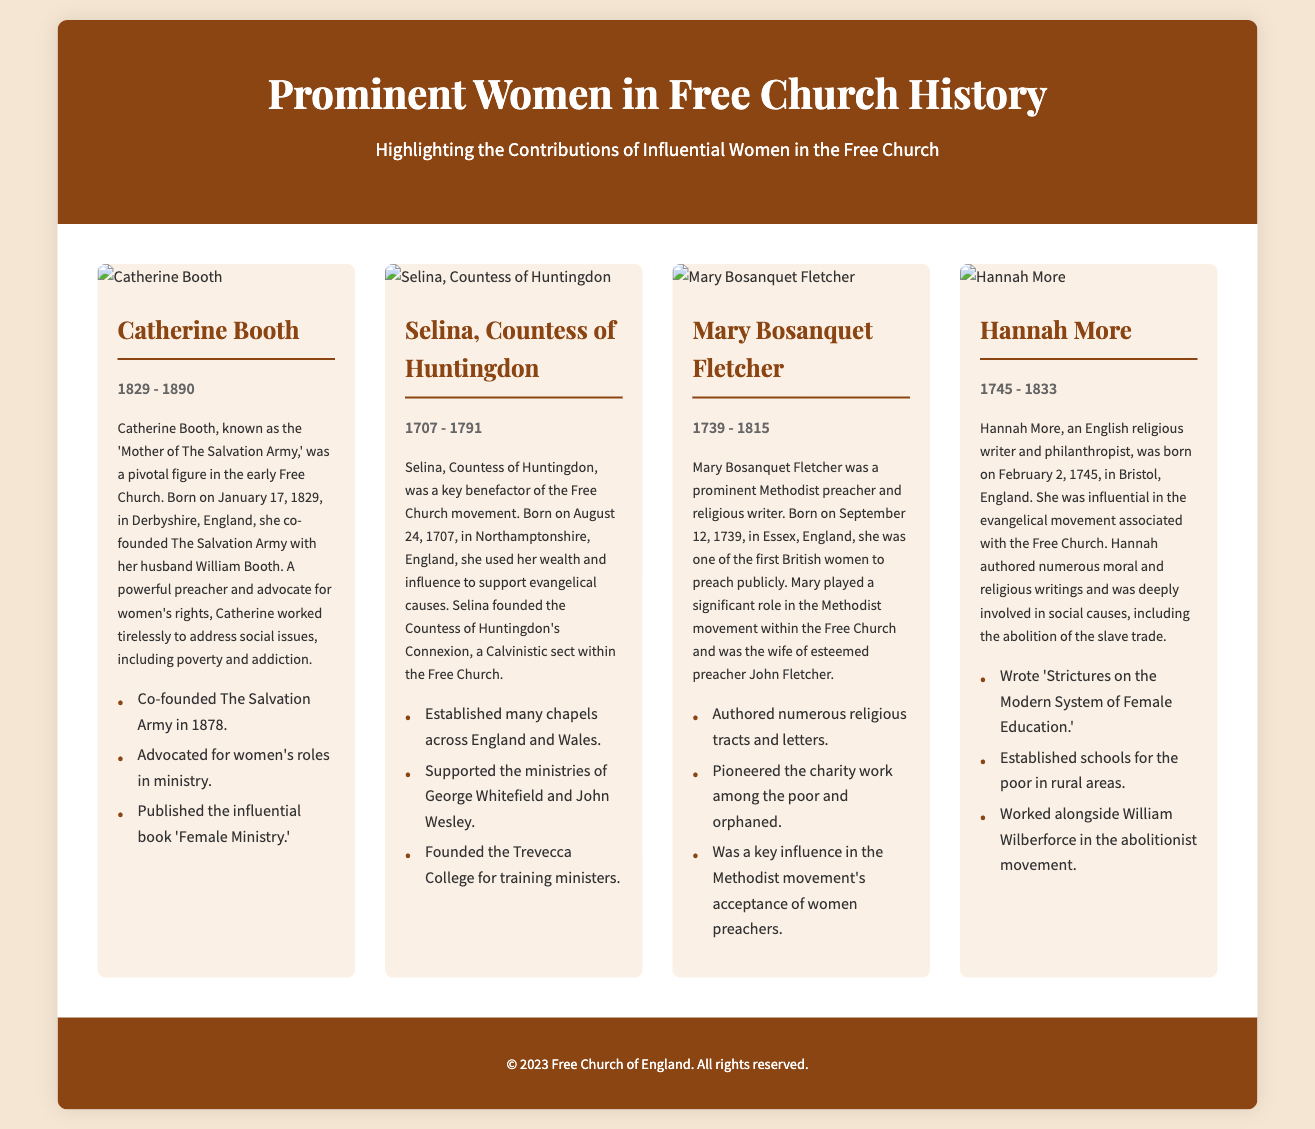what was the birth year of Catherine Booth? Catherine Booth was born on January 17, 1829, as stated in her biography.
Answer: 1829 who co-founded The Salvation Army? The document states that Catherine Booth co-founded The Salvation Army with her husband William Booth.
Answer: Catherine Booth what was the lifespan of Selina, Countess of Huntingdon? The document provides her birth and death dates, showing that she lived from 1707 to 1791.
Answer: 1707 - 1791 how many key contributions are listed for Hannah More? There are three contributions listed under Hannah More’s section, as highlighted in the document.
Answer: Three which woman was known as the 'Mother of The Salvation Army'? The document explicitly refers to Catherine Booth as the 'Mother of The Salvation Army.'
Answer: Catherine Booth what was the purpose of Trevecca College? According to Selina's biography, Trevecca College was founded for training ministers.
Answer: Training ministers who authored 'Strictures on the Modern System of Female Education'? The document indicates that Hannah More authored the book.
Answer: Hannah More what year did Mary Bosanquet Fletcher die? The biography of Mary Bosanquet Fletcher notes that she died in 1815.
Answer: 1815 which woman was involved in the abolition of the slave trade? The document mentions that Hannah More worked alongside William Wilberforce in the abolitionist movement.
Answer: Hannah More 